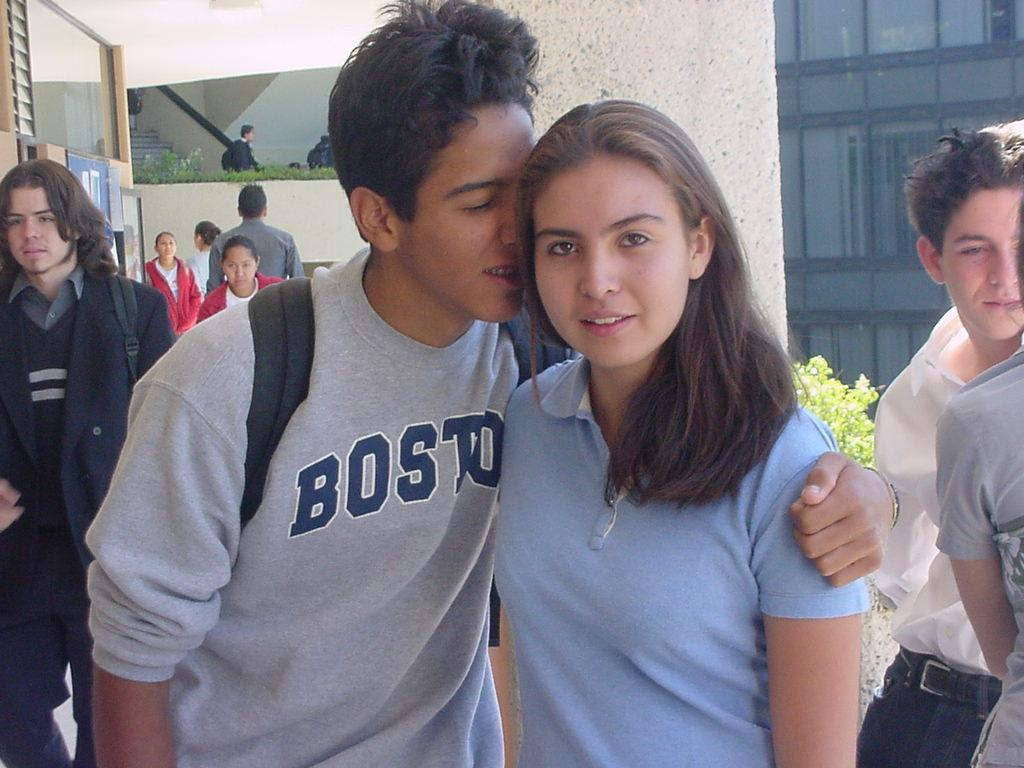How many people are present in the image? There are two people, a man and a woman, present in the image. What are the man and woman doing in the image? Both the man and woman are standing in the image. Can you describe the setting where the man and woman are located? There is a group of people standing in the image, and there are stairs, plants, and a building with glass doors present. What type of business is being conducted in the image? There is no indication of any business being conducted in the image; it simply shows a man and a woman standing with a group of people. 